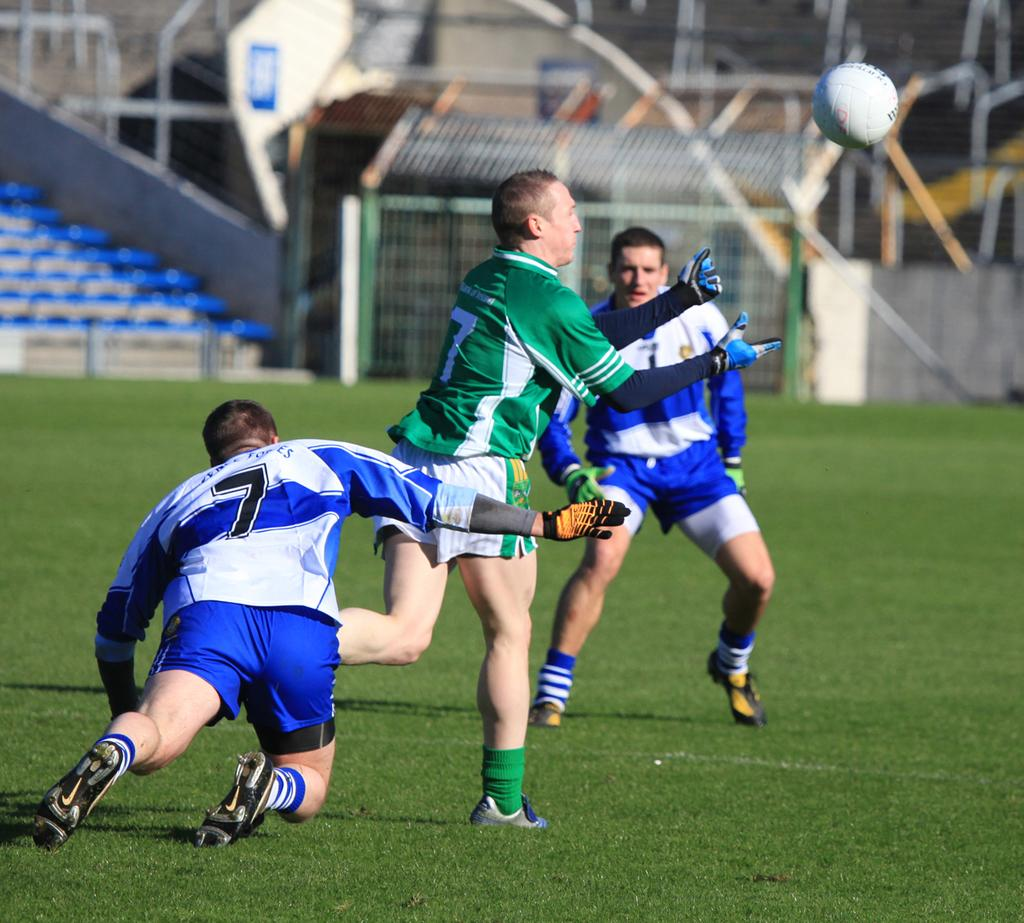<image>
Provide a brief description of the given image. members of two soccer teams playing a field, including the blue 7 and green 7 